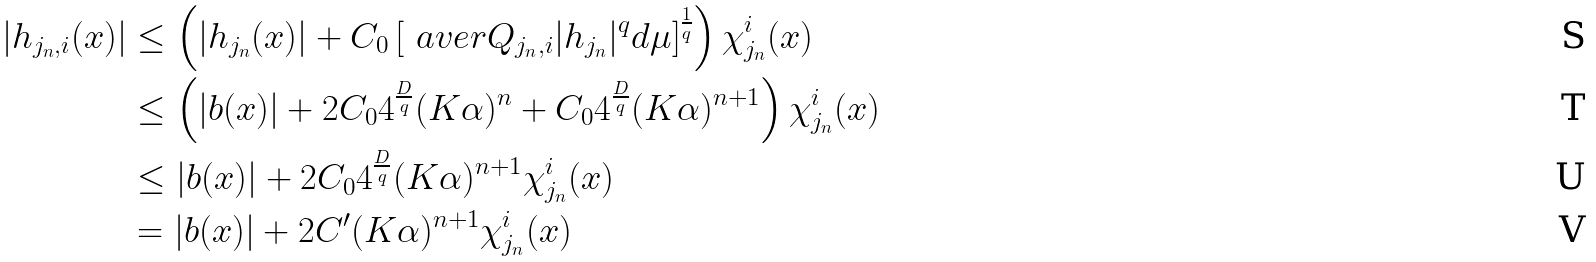<formula> <loc_0><loc_0><loc_500><loc_500>| h _ { j _ { n } , i } ( x ) | & \leq \left ( | h _ { j _ { n } } ( x ) | + C _ { 0 } \left [ \ a v e r { Q _ { j _ { n } , i } } | h _ { j _ { n } } | ^ { q } d \mu \right ] ^ { \frac { 1 } { q } } \right ) \chi _ { j _ { n } } ^ { i } ( x ) \\ & \leq \left ( | b ( x ) | + 2 C _ { 0 } 4 ^ { \frac { D } { q } } ( K \alpha ) ^ { n } + C _ { 0 } 4 ^ { \frac { D } { q } } ( K \alpha ) ^ { n + 1 } \right ) \chi _ { j _ { n } } ^ { i } ( x ) \\ & \leq | b ( x ) | + 2 C _ { 0 } 4 ^ { \frac { D } { q } } ( K \alpha ) ^ { n + 1 } \chi _ { j _ { n } } ^ { i } ( x ) \\ & = | b ( x ) | + 2 C ^ { \prime } ( K \alpha ) ^ { n + 1 } \chi _ { j _ { n } } ^ { i } ( x )</formula> 